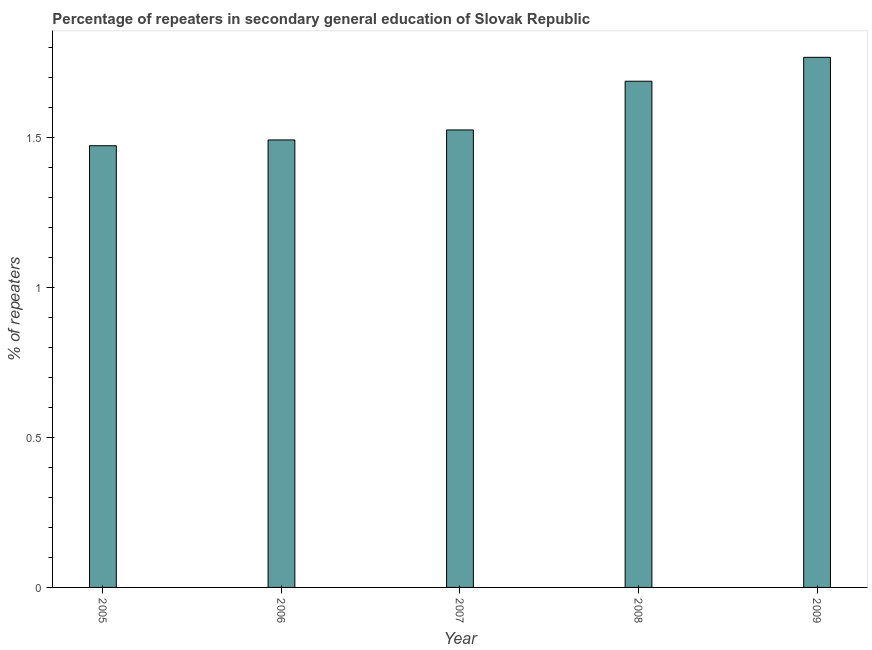Does the graph contain any zero values?
Your answer should be very brief. No. What is the title of the graph?
Provide a succinct answer. Percentage of repeaters in secondary general education of Slovak Republic. What is the label or title of the X-axis?
Make the answer very short. Year. What is the label or title of the Y-axis?
Make the answer very short. % of repeaters. What is the percentage of repeaters in 2007?
Provide a succinct answer. 1.53. Across all years, what is the maximum percentage of repeaters?
Your response must be concise. 1.77. Across all years, what is the minimum percentage of repeaters?
Your answer should be compact. 1.47. In which year was the percentage of repeaters maximum?
Keep it short and to the point. 2009. What is the sum of the percentage of repeaters?
Provide a succinct answer. 7.95. What is the difference between the percentage of repeaters in 2007 and 2008?
Keep it short and to the point. -0.16. What is the average percentage of repeaters per year?
Offer a terse response. 1.59. What is the median percentage of repeaters?
Make the answer very short. 1.53. In how many years, is the percentage of repeaters greater than 1.4 %?
Your answer should be very brief. 5. What is the difference between the highest and the lowest percentage of repeaters?
Offer a terse response. 0.29. In how many years, is the percentage of repeaters greater than the average percentage of repeaters taken over all years?
Keep it short and to the point. 2. How many bars are there?
Provide a succinct answer. 5. Are the values on the major ticks of Y-axis written in scientific E-notation?
Offer a very short reply. No. What is the % of repeaters of 2005?
Keep it short and to the point. 1.47. What is the % of repeaters of 2006?
Your answer should be very brief. 1.49. What is the % of repeaters in 2007?
Give a very brief answer. 1.53. What is the % of repeaters in 2008?
Your response must be concise. 1.69. What is the % of repeaters in 2009?
Give a very brief answer. 1.77. What is the difference between the % of repeaters in 2005 and 2006?
Offer a very short reply. -0.02. What is the difference between the % of repeaters in 2005 and 2007?
Your response must be concise. -0.05. What is the difference between the % of repeaters in 2005 and 2008?
Ensure brevity in your answer.  -0.22. What is the difference between the % of repeaters in 2005 and 2009?
Your answer should be compact. -0.29. What is the difference between the % of repeaters in 2006 and 2007?
Your response must be concise. -0.03. What is the difference between the % of repeaters in 2006 and 2008?
Your answer should be very brief. -0.2. What is the difference between the % of repeaters in 2006 and 2009?
Offer a terse response. -0.28. What is the difference between the % of repeaters in 2007 and 2008?
Your answer should be very brief. -0.16. What is the difference between the % of repeaters in 2007 and 2009?
Make the answer very short. -0.24. What is the difference between the % of repeaters in 2008 and 2009?
Offer a terse response. -0.08. What is the ratio of the % of repeaters in 2005 to that in 2006?
Keep it short and to the point. 0.99. What is the ratio of the % of repeaters in 2005 to that in 2008?
Ensure brevity in your answer.  0.87. What is the ratio of the % of repeaters in 2005 to that in 2009?
Make the answer very short. 0.83. What is the ratio of the % of repeaters in 2006 to that in 2007?
Your answer should be compact. 0.98. What is the ratio of the % of repeaters in 2006 to that in 2008?
Give a very brief answer. 0.88. What is the ratio of the % of repeaters in 2006 to that in 2009?
Ensure brevity in your answer.  0.84. What is the ratio of the % of repeaters in 2007 to that in 2008?
Give a very brief answer. 0.9. What is the ratio of the % of repeaters in 2007 to that in 2009?
Give a very brief answer. 0.86. What is the ratio of the % of repeaters in 2008 to that in 2009?
Keep it short and to the point. 0.95. 